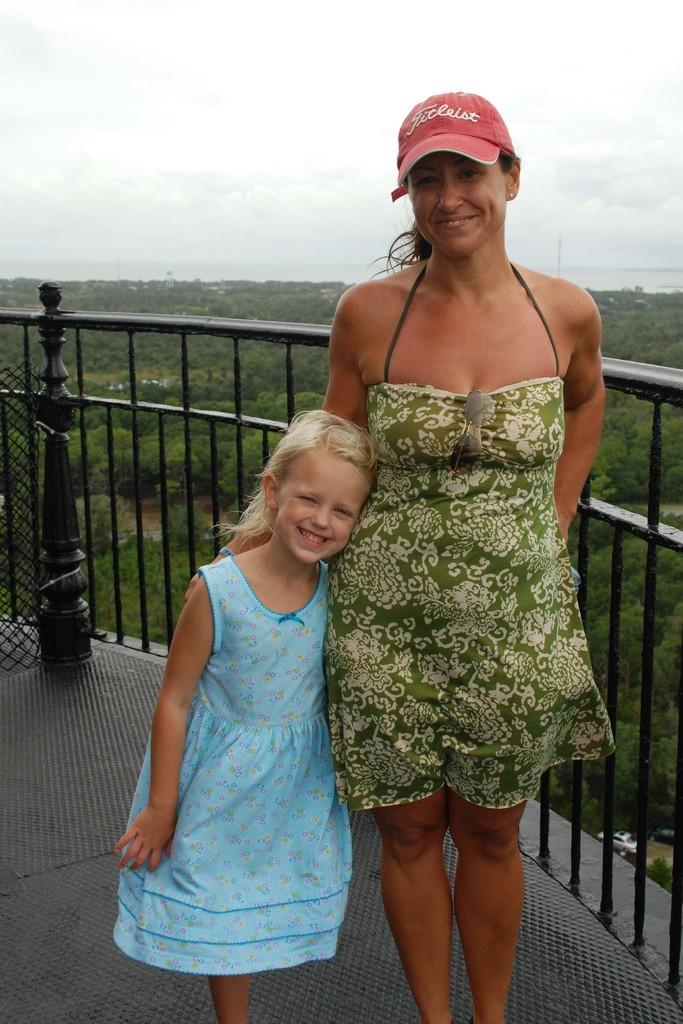What is the main subject of the image? There is a woman standing in the image. What is the woman wearing on her head? The woman is wearing a cap. Are there any other people in the image besides the woman? Yes, there is a girl standing alone with the woman. What can be seen in the background of the image? There are trees on the ground in the background of the image. What type of stick is the woman using to control the machine in the image? There is no stick or machine present in the image. 